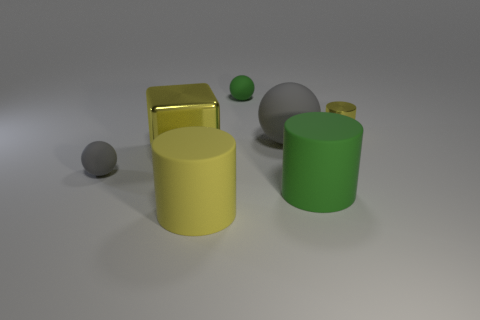How many yellow cylinders must be subtracted to get 1 yellow cylinders? 1 Subtract all large matte spheres. How many spheres are left? 2 Add 1 tiny green rubber things. How many objects exist? 8 Subtract all gray balls. How many balls are left? 1 Subtract all gray cylinders. How many gray balls are left? 2 Subtract 1 spheres. How many spheres are left? 2 Add 3 green matte cylinders. How many green matte cylinders exist? 4 Subtract 0 blue spheres. How many objects are left? 7 Subtract all blocks. How many objects are left? 6 Subtract all red cylinders. Subtract all brown spheres. How many cylinders are left? 3 